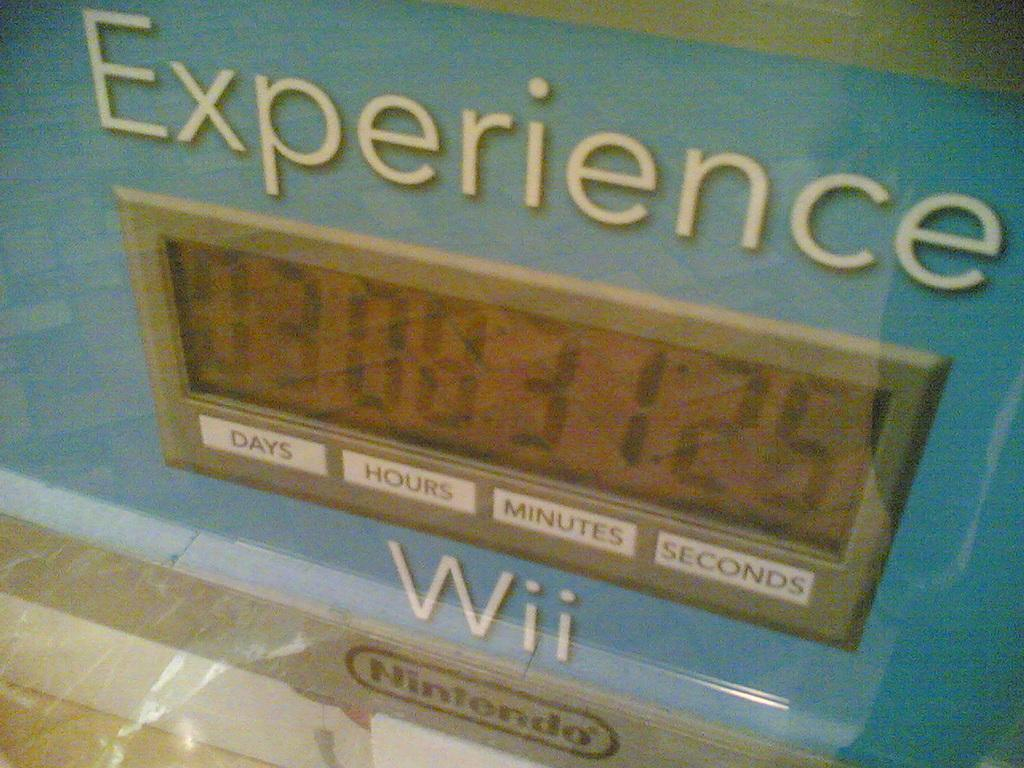<image>
Render a clear and concise summary of the photo. A Nintendo Wii counter which shows hours and minutes. 